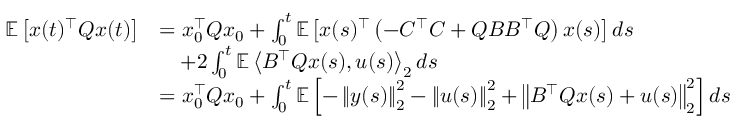Convert formula to latex. <formula><loc_0><loc_0><loc_500><loc_500>\begin{array} { r l } { \mathbb { E } \left [ x ( t ) ^ { \top } Q x ( t ) \right ] } & { = x _ { 0 } ^ { \top } Q x _ { 0 } + \int _ { 0 } ^ { t } \mathbb { E } \left [ x ( s ) ^ { \top } \left ( - C ^ { \top } C + Q B B ^ { \top } Q \right ) x ( s ) \right ] d s } \\ & { \quad + 2 \int _ { 0 } ^ { t } \mathbb { E } \left \langle B ^ { \top } Q x ( s ) , u ( s ) \right \rangle _ { 2 } d s } \\ & { = x _ { 0 } ^ { \top } Q x _ { 0 } + \int _ { 0 } ^ { t } \mathbb { E } \left [ - \left \| y ( s ) \right \| _ { 2 } ^ { 2 } - \left \| u ( s ) \right \| _ { 2 } ^ { 2 } + \left \| B ^ { \top } Q x ( s ) + u ( s ) \right \| _ { 2 } ^ { 2 } \right ] d s } \end{array}</formula> 